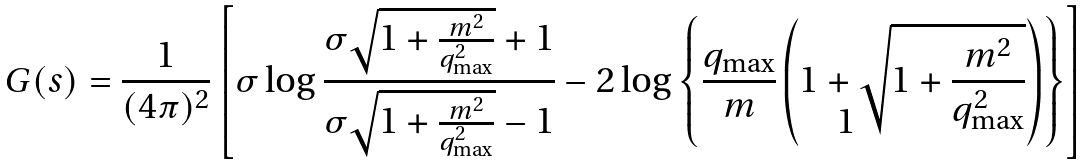Convert formula to latex. <formula><loc_0><loc_0><loc_500><loc_500>G ( s ) = \frac { 1 } { ( 4 \pi ) ^ { 2 } } \left [ \sigma \log \frac { \sigma \sqrt { 1 + \frac { m ^ { 2 } } { q _ { \max } ^ { 2 } } } + 1 } { \sigma \sqrt { 1 + \frac { m ^ { 2 } } { q _ { \max } ^ { 2 } } } - 1 } - 2 \log \left \{ \frac { q _ { \max } } { m } \left ( 1 + \sqrt { 1 + \frac { m ^ { 2 } } { q _ { \max } ^ { 2 } } } \right ) \right \} \right ]</formula> 